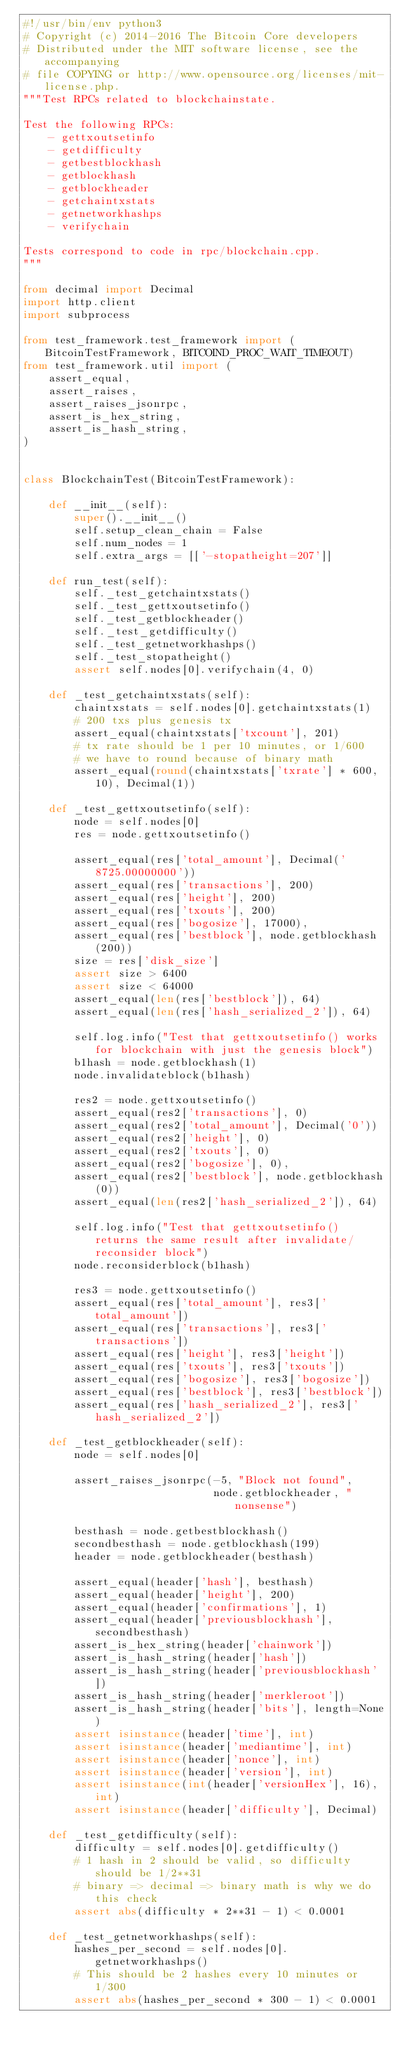Convert code to text. <code><loc_0><loc_0><loc_500><loc_500><_Python_>#!/usr/bin/env python3
# Copyright (c) 2014-2016 The Bitcoin Core developers
# Distributed under the MIT software license, see the accompanying
# file COPYING or http://www.opensource.org/licenses/mit-license.php.
"""Test RPCs related to blockchainstate.

Test the following RPCs:
    - gettxoutsetinfo
    - getdifficulty
    - getbestblockhash
    - getblockhash
    - getblockheader
    - getchaintxstats
    - getnetworkhashps
    - verifychain

Tests correspond to code in rpc/blockchain.cpp.
"""

from decimal import Decimal
import http.client
import subprocess

from test_framework.test_framework import (BitcoinTestFramework, BITCOIND_PROC_WAIT_TIMEOUT)
from test_framework.util import (
    assert_equal,
    assert_raises,
    assert_raises_jsonrpc,
    assert_is_hex_string,
    assert_is_hash_string,
)


class BlockchainTest(BitcoinTestFramework):

    def __init__(self):
        super().__init__()
        self.setup_clean_chain = False
        self.num_nodes = 1
        self.extra_args = [['-stopatheight=207']]

    def run_test(self):
        self._test_getchaintxstats()
        self._test_gettxoutsetinfo()
        self._test_getblockheader()
        self._test_getdifficulty()
        self._test_getnetworkhashps()
        self._test_stopatheight()
        assert self.nodes[0].verifychain(4, 0)

    def _test_getchaintxstats(self):
        chaintxstats = self.nodes[0].getchaintxstats(1)
        # 200 txs plus genesis tx
        assert_equal(chaintxstats['txcount'], 201)
        # tx rate should be 1 per 10 minutes, or 1/600
        # we have to round because of binary math
        assert_equal(round(chaintxstats['txrate'] * 600, 10), Decimal(1))

    def _test_gettxoutsetinfo(self):
        node = self.nodes[0]
        res = node.gettxoutsetinfo()

        assert_equal(res['total_amount'], Decimal('8725.00000000'))
        assert_equal(res['transactions'], 200)
        assert_equal(res['height'], 200)
        assert_equal(res['txouts'], 200)
        assert_equal(res['bogosize'], 17000),
        assert_equal(res['bestblock'], node.getblockhash(200))
        size = res['disk_size']
        assert size > 6400
        assert size < 64000
        assert_equal(len(res['bestblock']), 64)
        assert_equal(len(res['hash_serialized_2']), 64)

        self.log.info("Test that gettxoutsetinfo() works for blockchain with just the genesis block")
        b1hash = node.getblockhash(1)
        node.invalidateblock(b1hash)

        res2 = node.gettxoutsetinfo()
        assert_equal(res2['transactions'], 0)
        assert_equal(res2['total_amount'], Decimal('0'))
        assert_equal(res2['height'], 0)
        assert_equal(res2['txouts'], 0)
        assert_equal(res2['bogosize'], 0),
        assert_equal(res2['bestblock'], node.getblockhash(0))
        assert_equal(len(res2['hash_serialized_2']), 64)

        self.log.info("Test that gettxoutsetinfo() returns the same result after invalidate/reconsider block")
        node.reconsiderblock(b1hash)

        res3 = node.gettxoutsetinfo()
        assert_equal(res['total_amount'], res3['total_amount'])
        assert_equal(res['transactions'], res3['transactions'])
        assert_equal(res['height'], res3['height'])
        assert_equal(res['txouts'], res3['txouts'])
        assert_equal(res['bogosize'], res3['bogosize'])
        assert_equal(res['bestblock'], res3['bestblock'])
        assert_equal(res['hash_serialized_2'], res3['hash_serialized_2'])

    def _test_getblockheader(self):
        node = self.nodes[0]

        assert_raises_jsonrpc(-5, "Block not found",
                              node.getblockheader, "nonsense")

        besthash = node.getbestblockhash()
        secondbesthash = node.getblockhash(199)
        header = node.getblockheader(besthash)

        assert_equal(header['hash'], besthash)
        assert_equal(header['height'], 200)
        assert_equal(header['confirmations'], 1)
        assert_equal(header['previousblockhash'], secondbesthash)
        assert_is_hex_string(header['chainwork'])
        assert_is_hash_string(header['hash'])
        assert_is_hash_string(header['previousblockhash'])
        assert_is_hash_string(header['merkleroot'])
        assert_is_hash_string(header['bits'], length=None)
        assert isinstance(header['time'], int)
        assert isinstance(header['mediantime'], int)
        assert isinstance(header['nonce'], int)
        assert isinstance(header['version'], int)
        assert isinstance(int(header['versionHex'], 16), int)
        assert isinstance(header['difficulty'], Decimal)

    def _test_getdifficulty(self):
        difficulty = self.nodes[0].getdifficulty()
        # 1 hash in 2 should be valid, so difficulty should be 1/2**31
        # binary => decimal => binary math is why we do this check
        assert abs(difficulty * 2**31 - 1) < 0.0001

    def _test_getnetworkhashps(self):
        hashes_per_second = self.nodes[0].getnetworkhashps()
        # This should be 2 hashes every 10 minutes or 1/300
        assert abs(hashes_per_second * 300 - 1) < 0.0001
</code> 